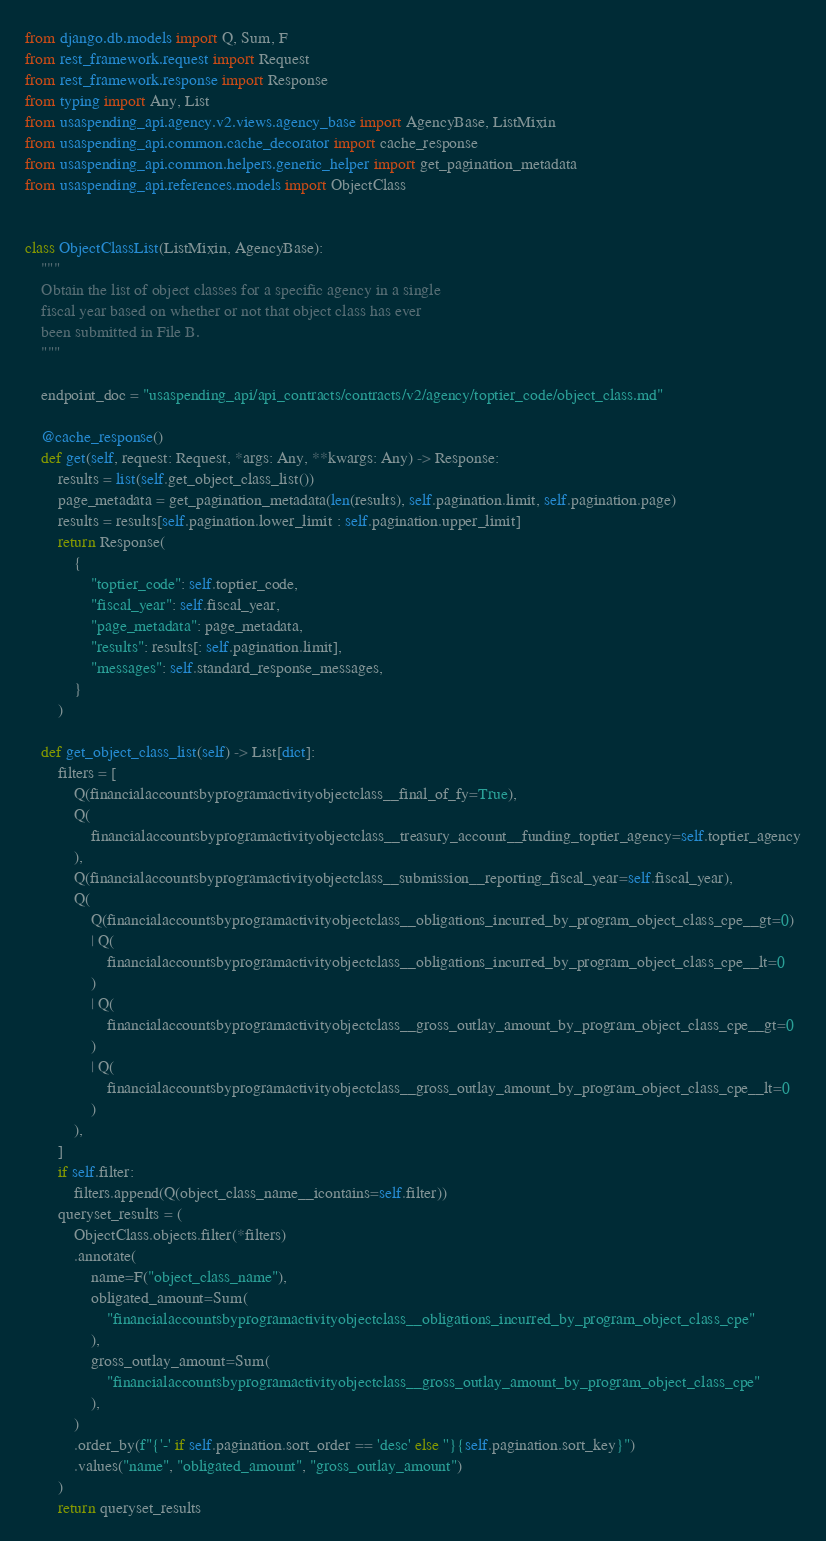Convert code to text. <code><loc_0><loc_0><loc_500><loc_500><_Python_>from django.db.models import Q, Sum, F
from rest_framework.request import Request
from rest_framework.response import Response
from typing import Any, List
from usaspending_api.agency.v2.views.agency_base import AgencyBase, ListMixin
from usaspending_api.common.cache_decorator import cache_response
from usaspending_api.common.helpers.generic_helper import get_pagination_metadata
from usaspending_api.references.models import ObjectClass


class ObjectClassList(ListMixin, AgencyBase):
    """
    Obtain the list of object classes for a specific agency in a single
    fiscal year based on whether or not that object class has ever
    been submitted in File B.
    """

    endpoint_doc = "usaspending_api/api_contracts/contracts/v2/agency/toptier_code/object_class.md"

    @cache_response()
    def get(self, request: Request, *args: Any, **kwargs: Any) -> Response:
        results = list(self.get_object_class_list())
        page_metadata = get_pagination_metadata(len(results), self.pagination.limit, self.pagination.page)
        results = results[self.pagination.lower_limit : self.pagination.upper_limit]
        return Response(
            {
                "toptier_code": self.toptier_code,
                "fiscal_year": self.fiscal_year,
                "page_metadata": page_metadata,
                "results": results[: self.pagination.limit],
                "messages": self.standard_response_messages,
            }
        )

    def get_object_class_list(self) -> List[dict]:
        filters = [
            Q(financialaccountsbyprogramactivityobjectclass__final_of_fy=True),
            Q(
                financialaccountsbyprogramactivityobjectclass__treasury_account__funding_toptier_agency=self.toptier_agency
            ),
            Q(financialaccountsbyprogramactivityobjectclass__submission__reporting_fiscal_year=self.fiscal_year),
            Q(
                Q(financialaccountsbyprogramactivityobjectclass__obligations_incurred_by_program_object_class_cpe__gt=0)
                | Q(
                    financialaccountsbyprogramactivityobjectclass__obligations_incurred_by_program_object_class_cpe__lt=0
                )
                | Q(
                    financialaccountsbyprogramactivityobjectclass__gross_outlay_amount_by_program_object_class_cpe__gt=0
                )
                | Q(
                    financialaccountsbyprogramactivityobjectclass__gross_outlay_amount_by_program_object_class_cpe__lt=0
                )
            ),
        ]
        if self.filter:
            filters.append(Q(object_class_name__icontains=self.filter))
        queryset_results = (
            ObjectClass.objects.filter(*filters)
            .annotate(
                name=F("object_class_name"),
                obligated_amount=Sum(
                    "financialaccountsbyprogramactivityobjectclass__obligations_incurred_by_program_object_class_cpe"
                ),
                gross_outlay_amount=Sum(
                    "financialaccountsbyprogramactivityobjectclass__gross_outlay_amount_by_program_object_class_cpe"
                ),
            )
            .order_by(f"{'-' if self.pagination.sort_order == 'desc' else ''}{self.pagination.sort_key}")
            .values("name", "obligated_amount", "gross_outlay_amount")
        )
        return queryset_results
</code> 